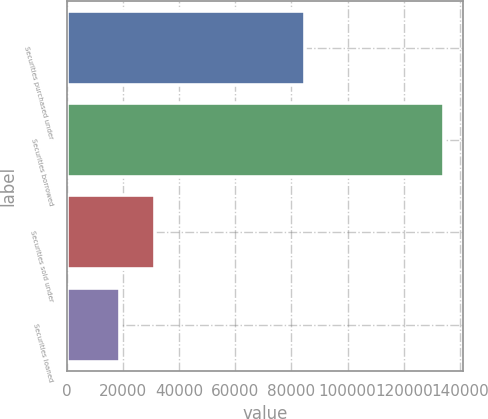Convert chart to OTSL. <chart><loc_0><loc_0><loc_500><loc_500><bar_chart><fcel>Securities purchased under<fcel>Securities borrowed<fcel>Securities sold under<fcel>Securities loaned<nl><fcel>84752<fcel>134250<fcel>31604<fcel>18881<nl></chart> 